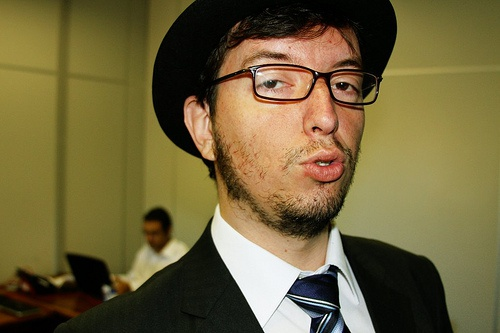Describe the objects in this image and their specific colors. I can see people in olive, black, tan, and white tones, people in olive, tan, black, and maroon tones, tie in olive, black, navy, white, and gray tones, and laptop in olive, black, and darkgreen tones in this image. 